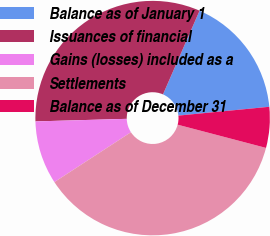Convert chart. <chart><loc_0><loc_0><loc_500><loc_500><pie_chart><fcel>Balance as of January 1<fcel>Issuances of financial<fcel>Gains (losses) included as a<fcel>Settlements<fcel>Balance as of December 31<nl><fcel>16.9%<fcel>32.01%<fcel>8.74%<fcel>36.72%<fcel>5.63%<nl></chart> 